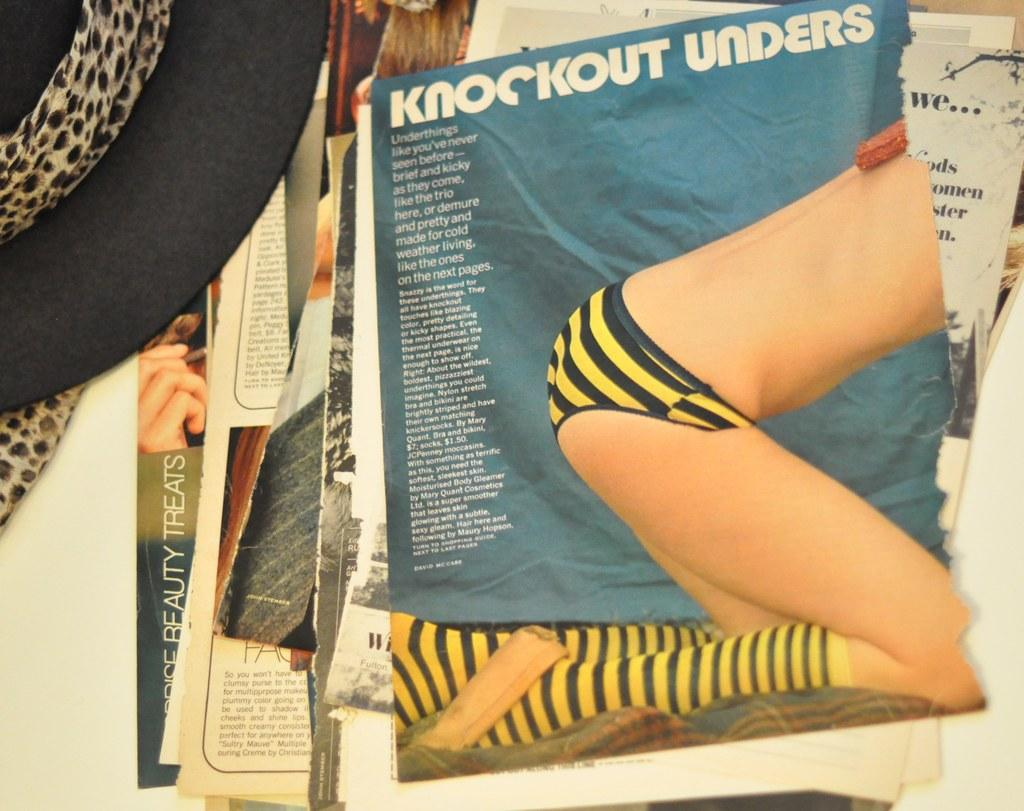<image>
Present a compact description of the photo's key features. Magazine articles laying on top of each other on the floor with the very first article referring to knockout unders. 